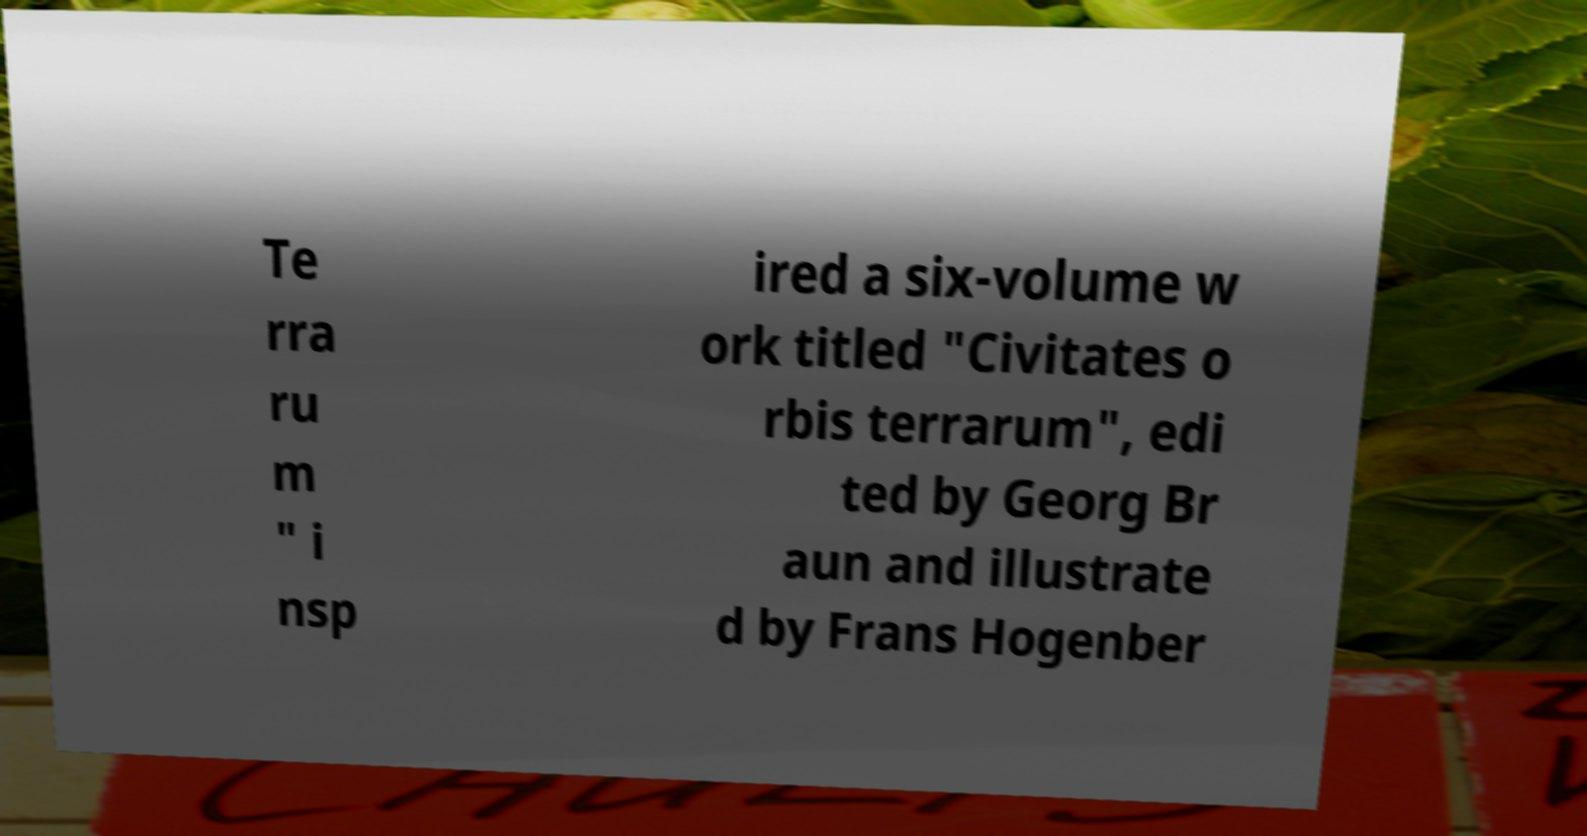I need the written content from this picture converted into text. Can you do that? Te rra ru m " i nsp ired a six-volume w ork titled "Civitates o rbis terrarum", edi ted by Georg Br aun and illustrate d by Frans Hogenber 